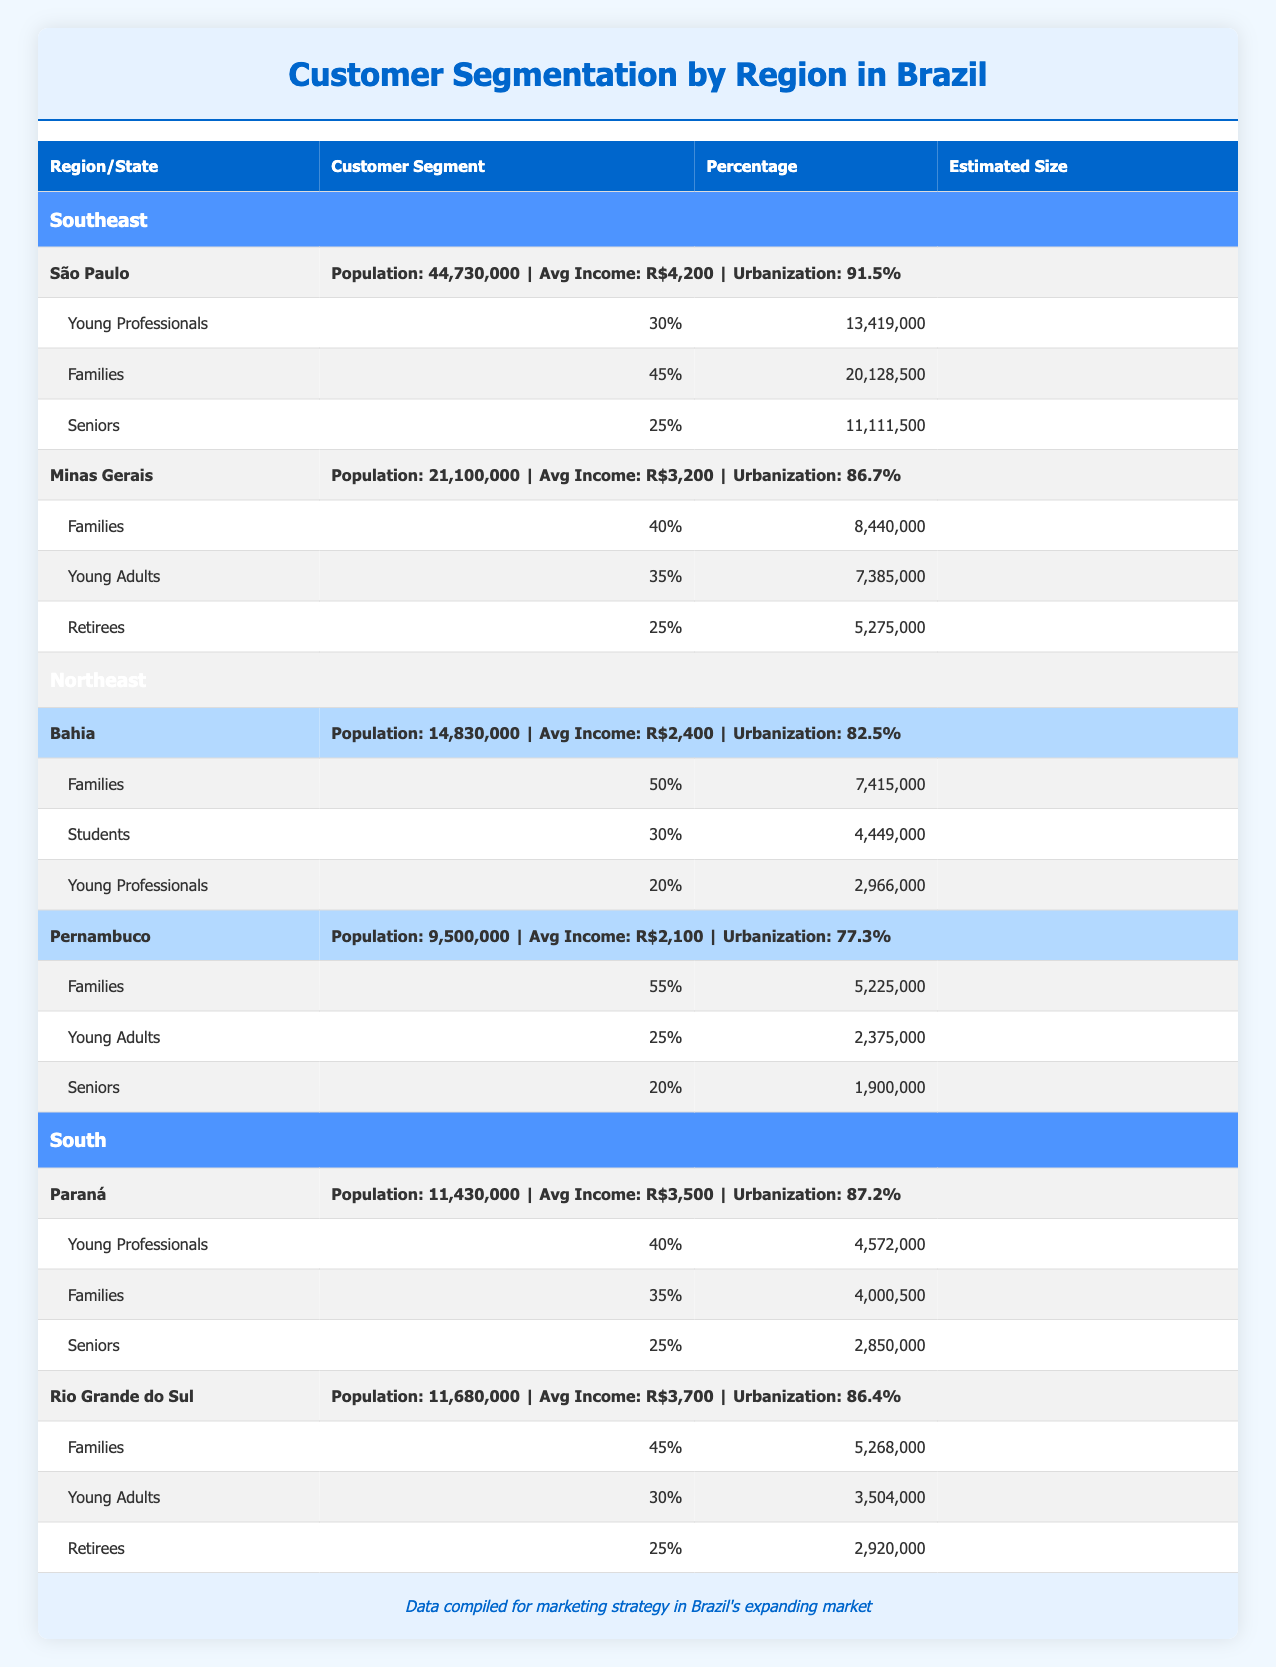What is the estimated size of the 'Families' segment in São Paulo? According to the table, the 'Families' segment in São Paulo has an estimated size of 20,128,500 people. This value is found directly in the table under the specific segment for the state of São Paulo.
Answer: 20,128,500 Which state in the Southeast has the highest percentage of 'Families' among its customer segments? In the Southeast region, Minas Gerais has the highest percentage of 'Families' at 40%. This can be determined by comparing the 'Families' percentages for both São Paulo and Minas Gerais.
Answer: Minas Gerais Is the average income higher in the Northeast region compared to the Southeast region? The average income in the Southeast region is R$4,200 (São Paulo) and R$3,200 (Minas Gerais), while in the Northeast, it is R$2,400 (Bahia) and R$2,100 (Pernambuco). Since both average incomes in the Southeast are higher than those in the Northeast, the statement is true.
Answer: No What is the total estimated size of all customer segments in Bahia? The estimated sizes for the customer segments in Bahia are: 'Families' (7,415,000), 'Students' (4,449,000), and 'Young Professionals' (2,966,000). Adding these together gives 7,415,000 + 4,449,000 + 2,966,000 = 14,830,000. Therefore, the total estimated size for all customer segments in Bahia is 14,830,000.
Answer: 14,830,000 How many more people are estimated to belong to the 'Young Adults' segment in Pernambuco than in Paraná? The estimated size of 'Young Adults' in Pernambuco is 2,375,000, while in Paraná the size is not listed as this customer segment is named 'Young Professionals' with 4,572,000. Since 4,572,000 (Paraná) is more than 2,375,000 (Pernambuco), the difference is 4,572,000 - 2,375,000 = 2,197,000.
Answer: 2,197,000 In which region do seniors make up a larger percentage of the customer segments, Southeast or South? In the Southeast region, 'Seniors' represent 25% in São Paulo and 25% in Minas Gerais, which averages to 25%. In the South region, 'Seniors' make up 25% in Paraná and 25% in Rio Grande do Sul, also averaging 25%. Thus, the percentages are equal, making it the same for both regions.
Answer: Same percentage What is the total estimated size of 'Young Professionals' across all states in the Southeast region? In the Southeast region, the estimated sizes for 'Young Professionals' are 13,419,000 (São Paulo) and 0 (Minas Gerais, where the segment is 'Young Adults'). Thus, adding these gives a total of 13,419,000.
Answer: 13,419,000 Do more 'Families' live in Pernambuco or Bahia? The estimated sizes for 'Families' are 5,225,000 in Pernambuco and 7,415,000 in Bahia. Since 7,415,000 is greater than 5,225,000, there are more 'Families' in Bahia.
Answer: Bahia 